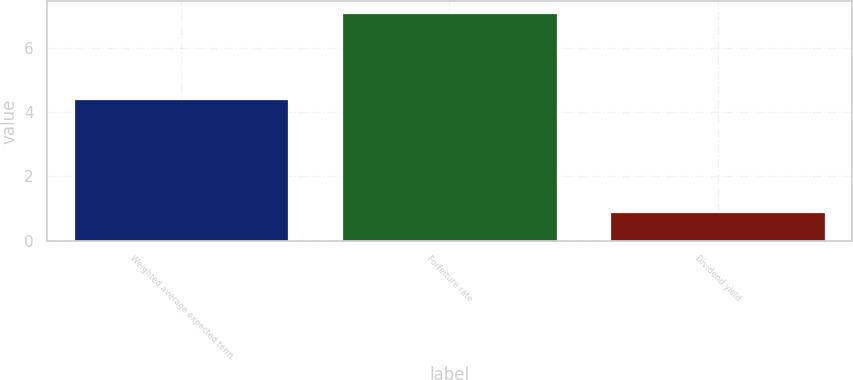Convert chart to OTSL. <chart><loc_0><loc_0><loc_500><loc_500><bar_chart><fcel>Weighted average expected term<fcel>Forfeiture rate<fcel>Dividend yield<nl><fcel>4.4<fcel>7.1<fcel>0.9<nl></chart> 